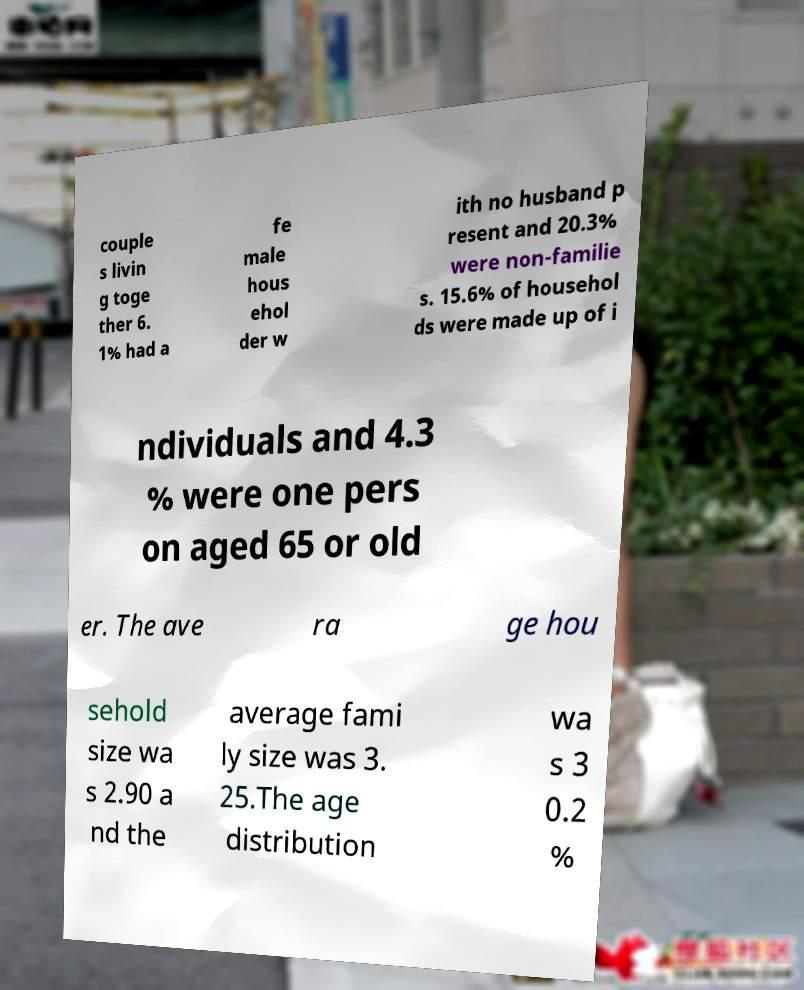Please identify and transcribe the text found in this image. couple s livin g toge ther 6. 1% had a fe male hous ehol der w ith no husband p resent and 20.3% were non-familie s. 15.6% of househol ds were made up of i ndividuals and 4.3 % were one pers on aged 65 or old er. The ave ra ge hou sehold size wa s 2.90 a nd the average fami ly size was 3. 25.The age distribution wa s 3 0.2 % 